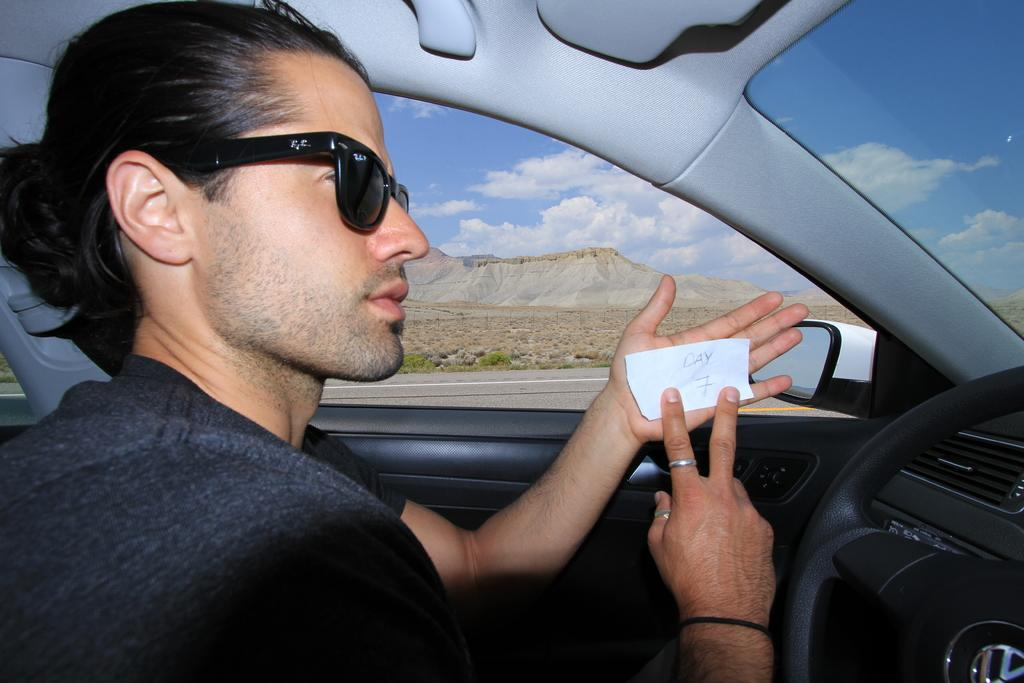Who is present in the image? There is a man in the image. What is the man doing in the image? The man is sitting in a car. What is the man holding in the image? The man is holding a paper. What accessory is the man wearing in the image? The man is wearing sunglasses. What month is it in the image? The month cannot be determined from the image, as there is no information about the date or time of year. 